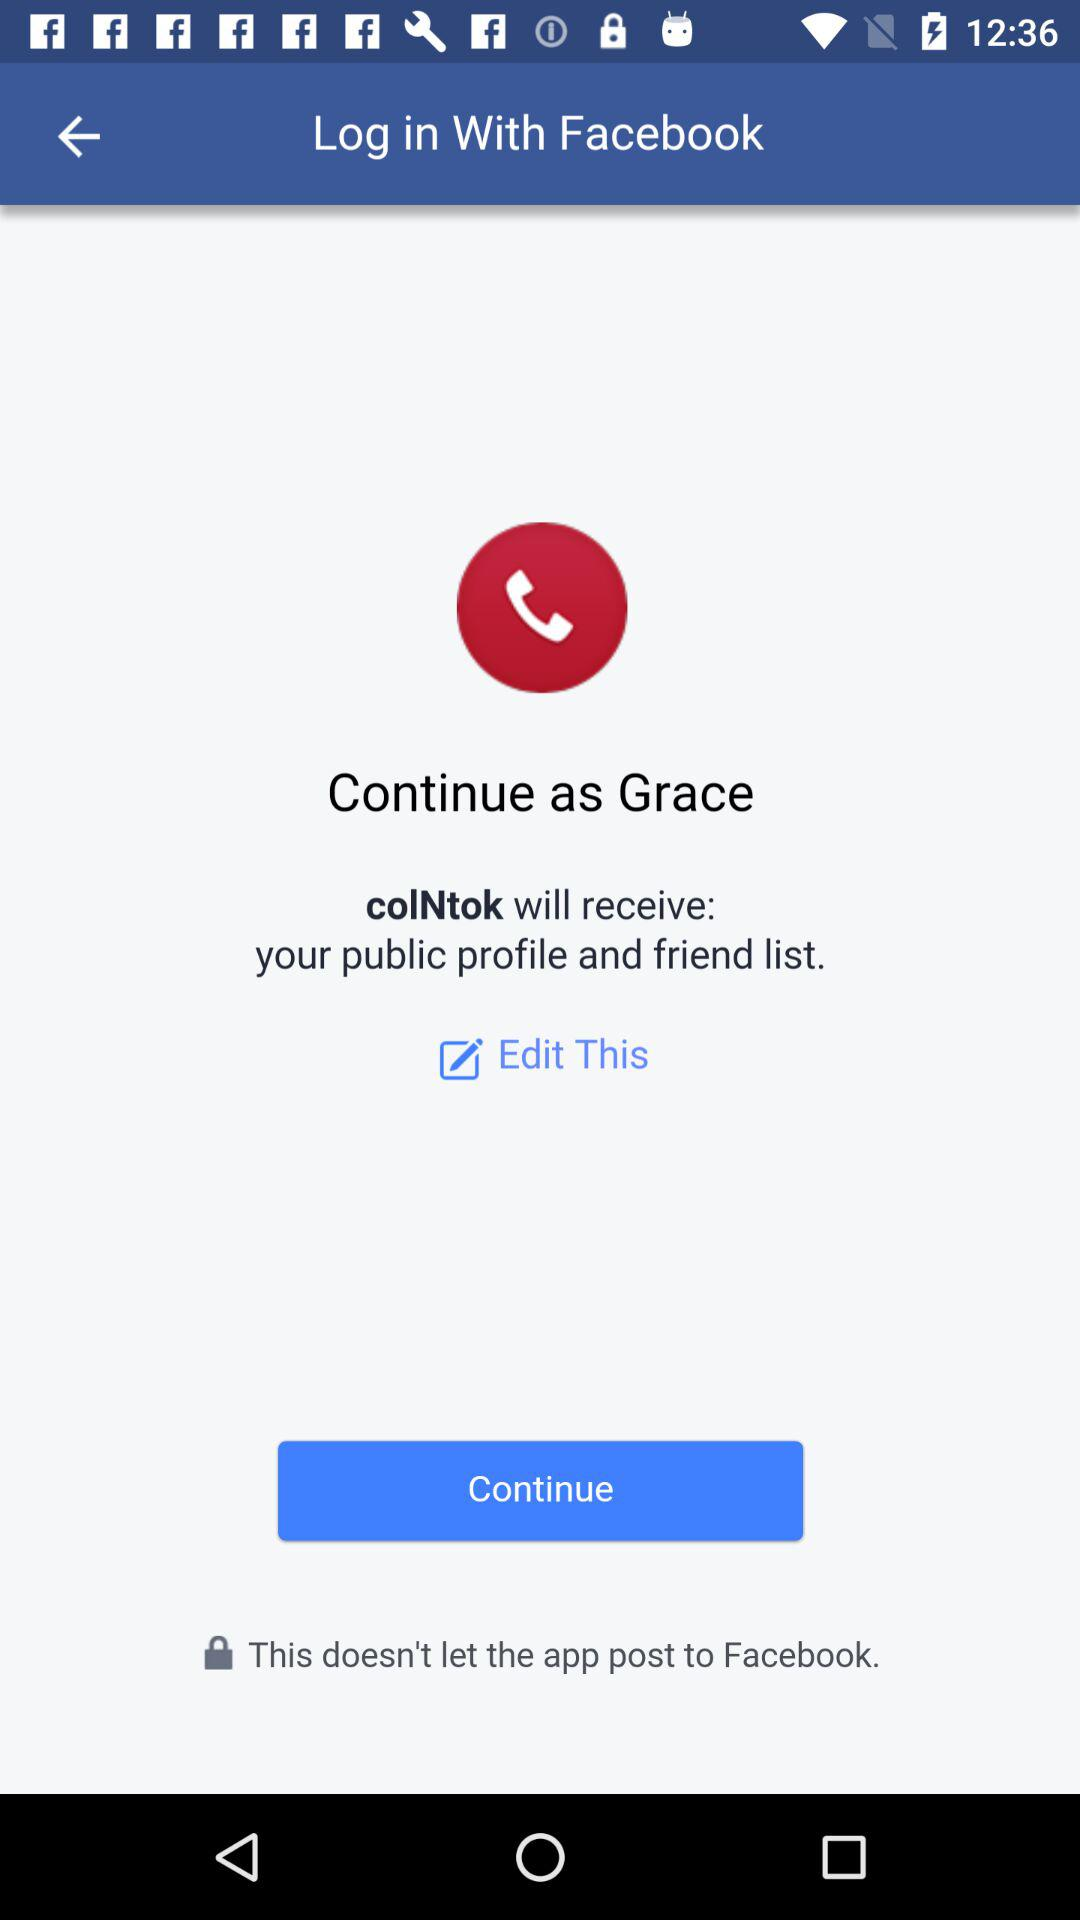What application is asking for permission? The application asking for permission is "colNtok". 